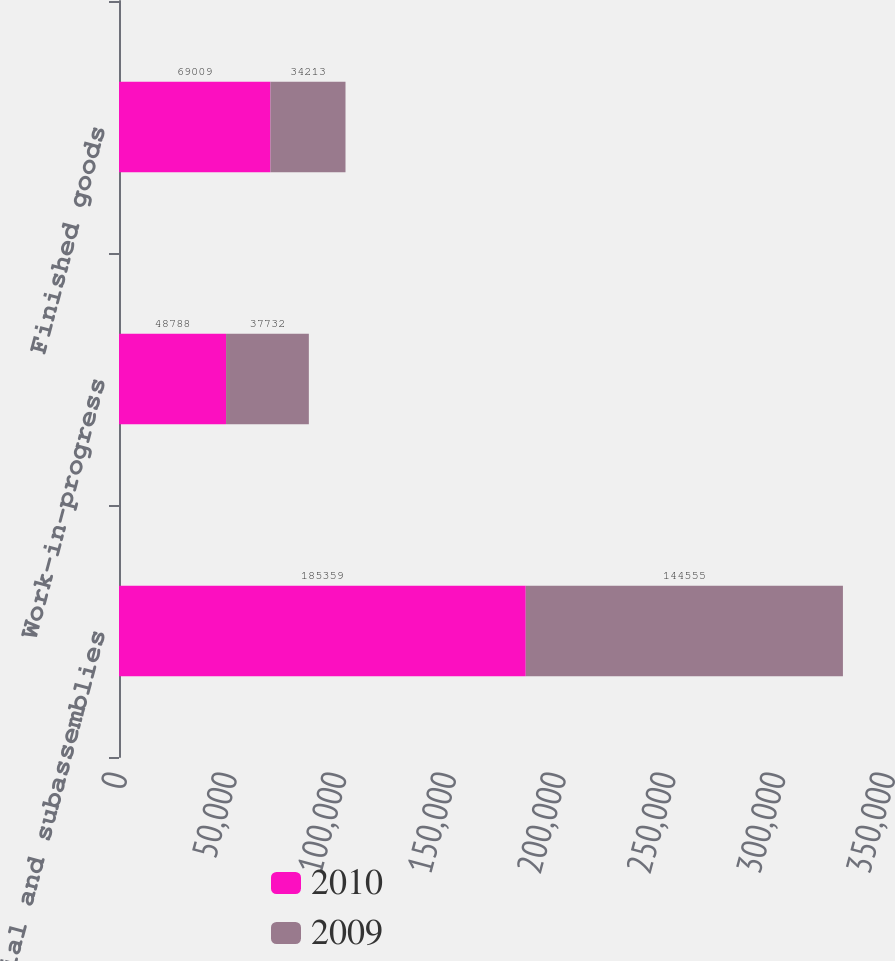<chart> <loc_0><loc_0><loc_500><loc_500><stacked_bar_chart><ecel><fcel>Raw material and subassemblies<fcel>Work-in-progress<fcel>Finished goods<nl><fcel>2010<fcel>185359<fcel>48788<fcel>69009<nl><fcel>2009<fcel>144555<fcel>37732<fcel>34213<nl></chart> 